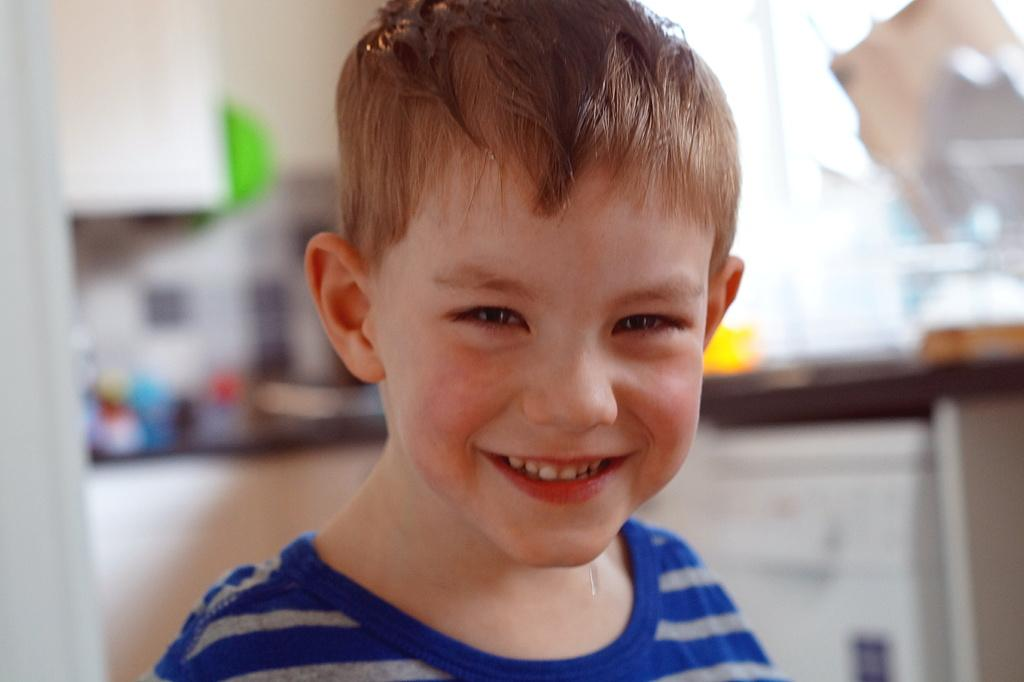What is the main subject of the image? The main subject of the image is a kid. What is the kid doing in the image? The kid is standing and smiling. What other object can be seen in the image? There is a table in the image. Can you describe the background of the image? The background of the image is blurred. What type of yarn is the kid holding in the image? There is no yarn present in the image; the kid is not holding anything. Can you see a horse in the background of the image? There is no horse present in the image; the background is blurred and does not show any specific objects or animals. 